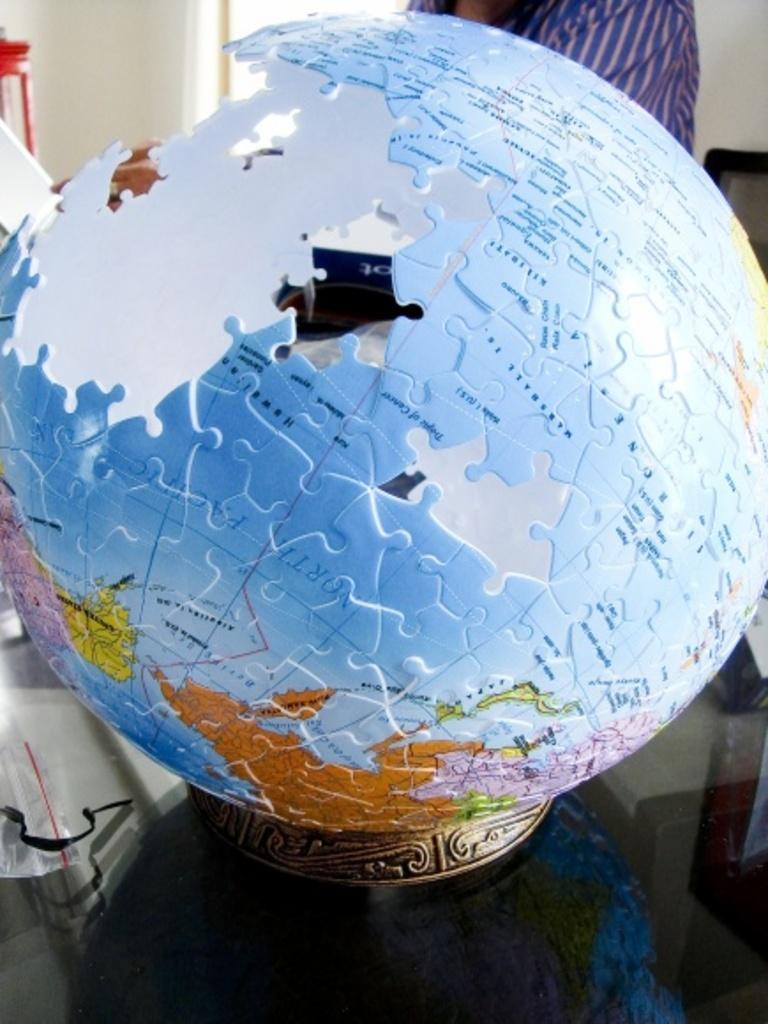Describe this image in one or two sentences. In this picture we can see a globe. There is a person and a wall in the background. 